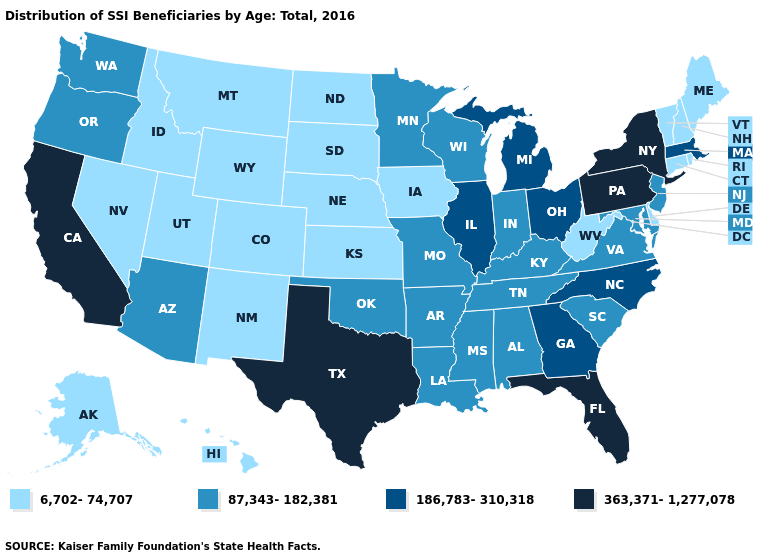What is the value of Delaware?
Write a very short answer. 6,702-74,707. What is the highest value in the South ?
Give a very brief answer. 363,371-1,277,078. Among the states that border New Mexico , which have the highest value?
Give a very brief answer. Texas. What is the highest value in the USA?
Keep it brief. 363,371-1,277,078. Among the states that border Iowa , which have the lowest value?
Keep it brief. Nebraska, South Dakota. What is the value of South Carolina?
Quick response, please. 87,343-182,381. Does Georgia have the lowest value in the USA?
Keep it brief. No. Does Ohio have the lowest value in the USA?
Be succinct. No. What is the lowest value in the USA?
Keep it brief. 6,702-74,707. What is the lowest value in states that border Arizona?
Quick response, please. 6,702-74,707. Name the states that have a value in the range 363,371-1,277,078?
Keep it brief. California, Florida, New York, Pennsylvania, Texas. Does Alabama have the same value as North Dakota?
Concise answer only. No. What is the highest value in the MidWest ?
Quick response, please. 186,783-310,318. Name the states that have a value in the range 186,783-310,318?
Concise answer only. Georgia, Illinois, Massachusetts, Michigan, North Carolina, Ohio. What is the lowest value in the West?
Concise answer only. 6,702-74,707. 